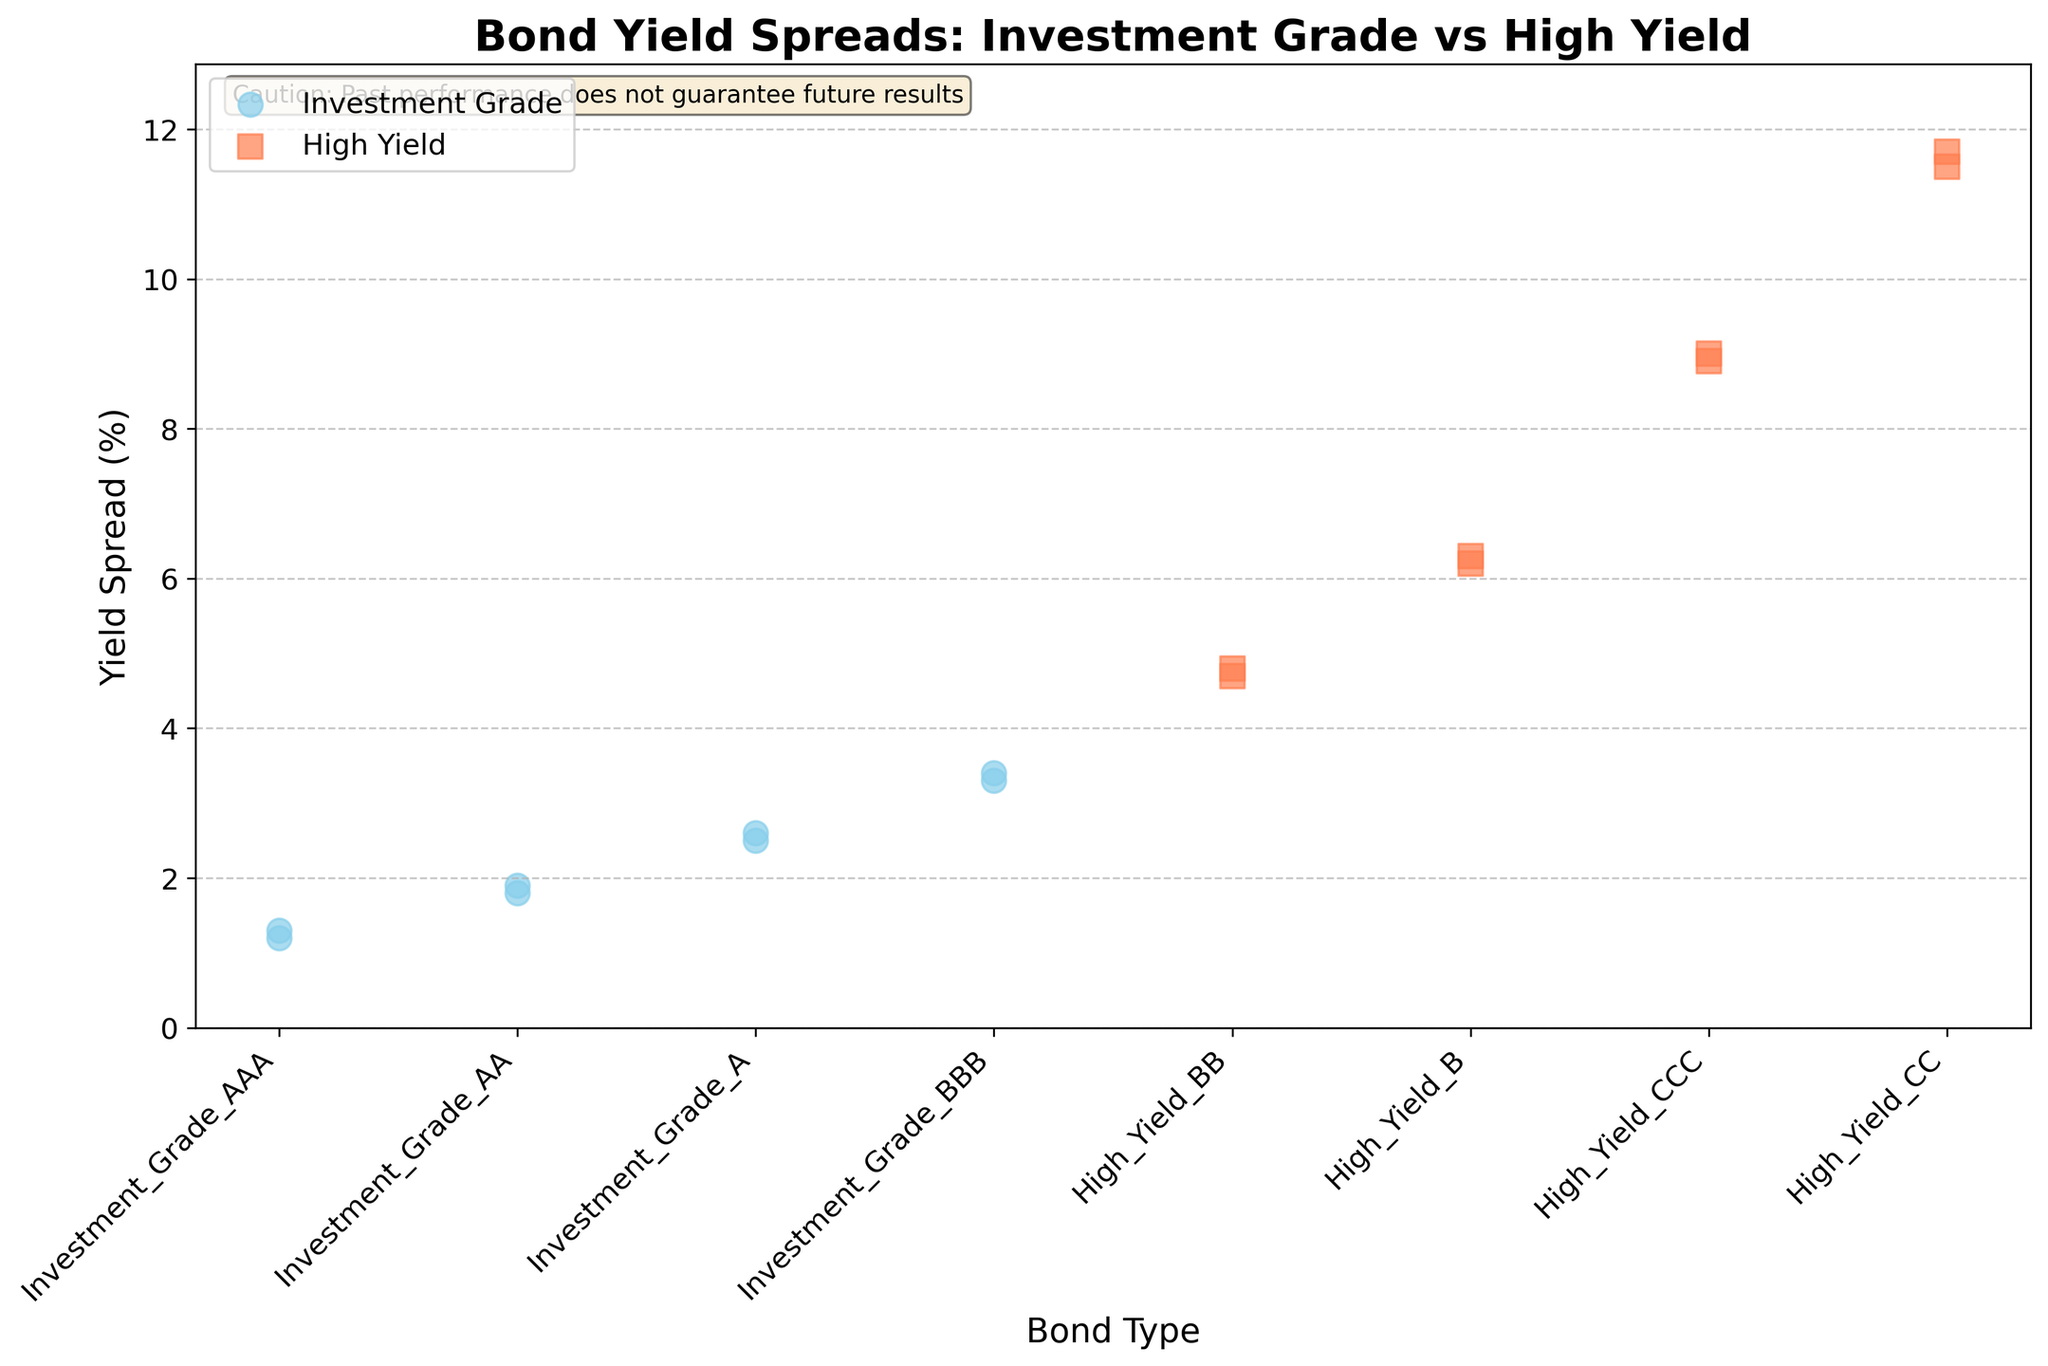Which bond type has the lowest yield spread? The figure shows multiple data points, with the lowest yield spread being around 1.2%. This is associated with the 'Investment_Grade_AAA' bond type.
Answer: Investment_Grade_AAA How many bond types are shown in the plot? The x-axis labels correspond to the bond types. There are four bond types under 'Investment Grade' and four under 'High Yield', making a total of eight bond types.
Answer: 8 What is the average yield spread of 'High_Yield_BB' bonds? There are two data points for the 'High_Yield_BB' bond type: 4.7% and 4.8%. The average is calculated as (4.7 + 4.8)/2 = 4.75%.
Answer: 4.75% Which bond type has the highest yield spread? The figure shows the yield spreads with 'High_Yield_CC' having the highest yield spread around 11.7%.
Answer: High_Yield_CC What is the range of yield spreads for 'Investment_Grade_BBB' bonds? The two data points for the 'Investment_Grade_BBB' bond type are 3.3% and 3.4%. The range is the difference between the highest and lowest value, 3.4 - 3.3 = 0.1%.
Answer: 0.1% Compare the yield spreads of 'Investment_Grade_A' and 'High_Yield_B'. Which is higher and by how much? The figure shows the yield spread of 'Investment_Grade_A' bonds is around 2.5% and 2.6%, while 'High_Yield_B' is around 6.2% and 6.3%. The average yield spread for 'Investment_Grade_A' is (2.5 + 2.6)/2 = 2.55%, and for 'High_Yield_B' is (6.2 + 6.3)/2 = 6.25%. The difference is 6.25 - 2.55 = 3.7%.
Answer: High_Yield_B, 3.7% What is the overall trend observed between the ratings of bonds and their yield spreads? As the credit rating of bonds decreases from 'Investment_Grade_AAA' to 'High_Yield_CC', the yield spreads generally increase. This trend is evident from the figure where the leftmost points (Investment Grade) have lower yield spreads and the rightmost points (High Yield) have higher yield spreads.
Answer: Yield spreads increase as credit ratings decrease How many data points are plotted for 'High_Yield_CCC' bonds? The strip plot shows two distinct data points associated with 'High_Yield_CCC' bonds.
Answer: 2 Are there any overlaps in the yield spreads between 'Investment Grade' and 'High Yield' bonds? Yes, the yield spreads of 'Investment_Grade_BBB' (3.3% and 3.4%) are close to the lower end of 'High_Yield_BB' (4.7% and 4.8%). However, they do not overlap directly, as the lowest 'High_Yield_BB' is higher than the highest 'Investment_Grade_BBB'.
Answer: No direct overlaps Based on the figure, which bond type is potentially the riskiest investment and why? 'High_Yield_CC' bonds appear to have the highest yield spreads at 11.5% and 11.7%, indicating the market requires a high yield to compensate for the perceived risk. Higher yields generally imply higher risk.
Answer: High_Yield_CC 